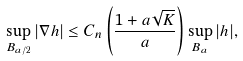<formula> <loc_0><loc_0><loc_500><loc_500>\sup _ { B _ { a / 2 } } | \nabla h | \leq C _ { n } \left ( \frac { 1 + a \sqrt { K } } { a } \right ) \sup _ { B _ { a } } | h | ,</formula> 